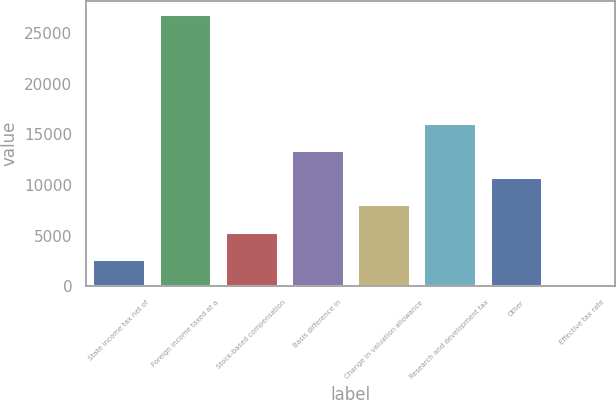Convert chart. <chart><loc_0><loc_0><loc_500><loc_500><bar_chart><fcel>State income tax net of<fcel>Foreign income taxed at a<fcel>Stock-based compensation<fcel>Basis difference in<fcel>Change in valuation allowance<fcel>Research and development tax<fcel>Other<fcel>Effective tax rate<nl><fcel>2705.7<fcel>26886<fcel>5392.4<fcel>13452.5<fcel>8079.1<fcel>16139.2<fcel>10765.8<fcel>19<nl></chart> 